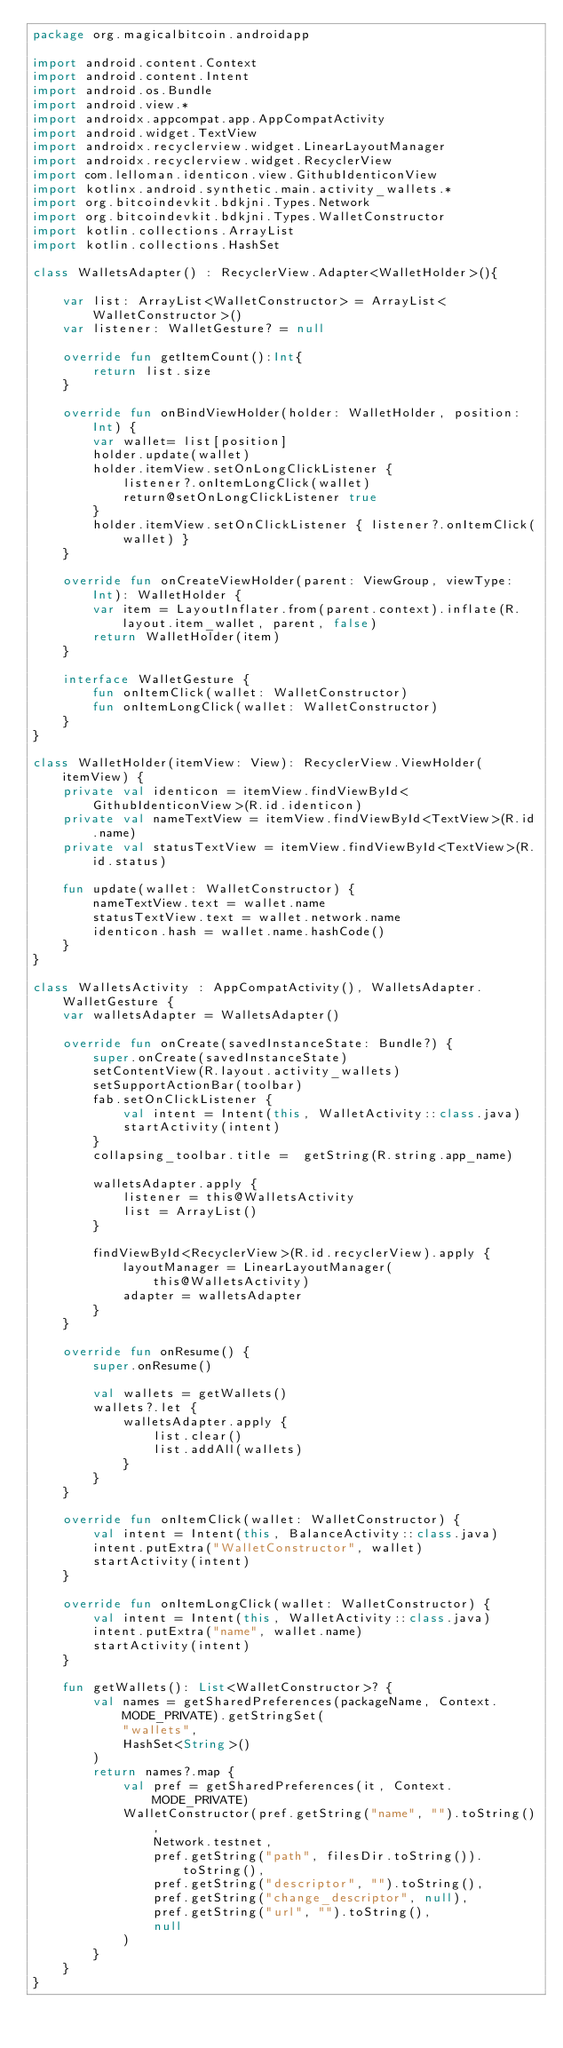<code> <loc_0><loc_0><loc_500><loc_500><_Kotlin_>package org.magicalbitcoin.androidapp

import android.content.Context
import android.content.Intent
import android.os.Bundle
import android.view.*
import androidx.appcompat.app.AppCompatActivity
import android.widget.TextView
import androidx.recyclerview.widget.LinearLayoutManager
import androidx.recyclerview.widget.RecyclerView
import com.lelloman.identicon.view.GithubIdenticonView
import kotlinx.android.synthetic.main.activity_wallets.*
import org.bitcoindevkit.bdkjni.Types.Network
import org.bitcoindevkit.bdkjni.Types.WalletConstructor
import kotlin.collections.ArrayList
import kotlin.collections.HashSet

class WalletsAdapter() : RecyclerView.Adapter<WalletHolder>(){

    var list: ArrayList<WalletConstructor> = ArrayList<WalletConstructor>()
    var listener: WalletGesture? = null

    override fun getItemCount():Int{
        return list.size
    }

    override fun onBindViewHolder(holder: WalletHolder, position: Int) {
        var wallet= list[position]
        holder.update(wallet)
        holder.itemView.setOnLongClickListener {
            listener?.onItemLongClick(wallet)
            return@setOnLongClickListener true
        }
        holder.itemView.setOnClickListener { listener?.onItemClick(wallet) }
    }

    override fun onCreateViewHolder(parent: ViewGroup, viewType: Int): WalletHolder {
        var item = LayoutInflater.from(parent.context).inflate(R.layout.item_wallet, parent, false)
        return WalletHolder(item)
    }

    interface WalletGesture {
        fun onItemClick(wallet: WalletConstructor)
        fun onItemLongClick(wallet: WalletConstructor)
    }
}

class WalletHolder(itemView: View): RecyclerView.ViewHolder(itemView) {
    private val identicon = itemView.findViewById<GithubIdenticonView>(R.id.identicon)
    private val nameTextView = itemView.findViewById<TextView>(R.id.name)
    private val statusTextView = itemView.findViewById<TextView>(R.id.status)

    fun update(wallet: WalletConstructor) {
        nameTextView.text = wallet.name
        statusTextView.text = wallet.network.name
        identicon.hash = wallet.name.hashCode()
    }
}

class WalletsActivity : AppCompatActivity(), WalletsAdapter.WalletGesture {
    var walletsAdapter = WalletsAdapter()

    override fun onCreate(savedInstanceState: Bundle?) {
        super.onCreate(savedInstanceState)
        setContentView(R.layout.activity_wallets)
        setSupportActionBar(toolbar)
        fab.setOnClickListener {
            val intent = Intent(this, WalletActivity::class.java)
            startActivity(intent)
        }
        collapsing_toolbar.title =  getString(R.string.app_name)

        walletsAdapter.apply {
            listener = this@WalletsActivity
            list = ArrayList()
        }

        findViewById<RecyclerView>(R.id.recyclerView).apply {
            layoutManager = LinearLayoutManager(this@WalletsActivity)
            adapter = walletsAdapter
        }
    }

    override fun onResume() {
        super.onResume()

        val wallets = getWallets()
        wallets?.let {
            walletsAdapter.apply {
                list.clear()
                list.addAll(wallets)
            }
        }
    }

    override fun onItemClick(wallet: WalletConstructor) {
        val intent = Intent(this, BalanceActivity::class.java)
        intent.putExtra("WalletConstructor", wallet)
        startActivity(intent)
    }

    override fun onItemLongClick(wallet: WalletConstructor) {
        val intent = Intent(this, WalletActivity::class.java)
        intent.putExtra("name", wallet.name)
        startActivity(intent)
    }

    fun getWallets(): List<WalletConstructor>? {
        val names = getSharedPreferences(packageName, Context.MODE_PRIVATE).getStringSet(
            "wallets",
            HashSet<String>()
        )
        return names?.map {
            val pref = getSharedPreferences(it, Context.MODE_PRIVATE)
            WalletConstructor(pref.getString("name", "").toString(),
                Network.testnet,
                pref.getString("path", filesDir.toString()).toString(),
                pref.getString("descriptor", "").toString(),
                pref.getString("change_descriptor", null),
                pref.getString("url", "").toString(),
                null
            )
        }
    }
}
</code> 